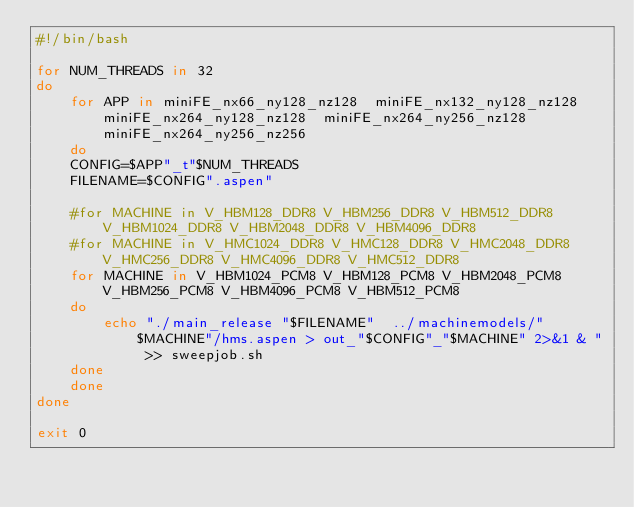<code> <loc_0><loc_0><loc_500><loc_500><_Bash_>#!/bin/bash

for NUM_THREADS in 32
do
    for APP in miniFE_nx66_ny128_nz128  miniFE_nx132_ny128_nz128  miniFE_nx264_ny128_nz128  miniFE_nx264_ny256_nz128 miniFE_nx264_ny256_nz256
    do
	CONFIG=$APP"_t"$NUM_THREADS
	FILENAME=$CONFIG".aspen"

	#for MACHINE in V_HBM128_DDR8 V_HBM256_DDR8 V_HBM512_DDR8 V_HBM1024_DDR8 V_HBM2048_DDR8 V_HBM4096_DDR8
	#for MACHINE in V_HMC1024_DDR8 V_HMC128_DDR8 V_HMC2048_DDR8 V_HMC256_DDR8 V_HMC4096_DDR8 V_HMC512_DDR8 
	for MACHINE in V_HBM1024_PCM8 V_HBM128_PCM8 V_HBM2048_PCM8 V_HBM256_PCM8 V_HBM4096_PCM8 V_HBM512_PCM8
	do
	    echo "./main_release "$FILENAME"  ../machinemodels/"$MACHINE"/hms.aspen > out_"$CONFIG"_"$MACHINE" 2>&1 & " >> sweepjob.sh
	done
    done
done

exit 0
</code> 